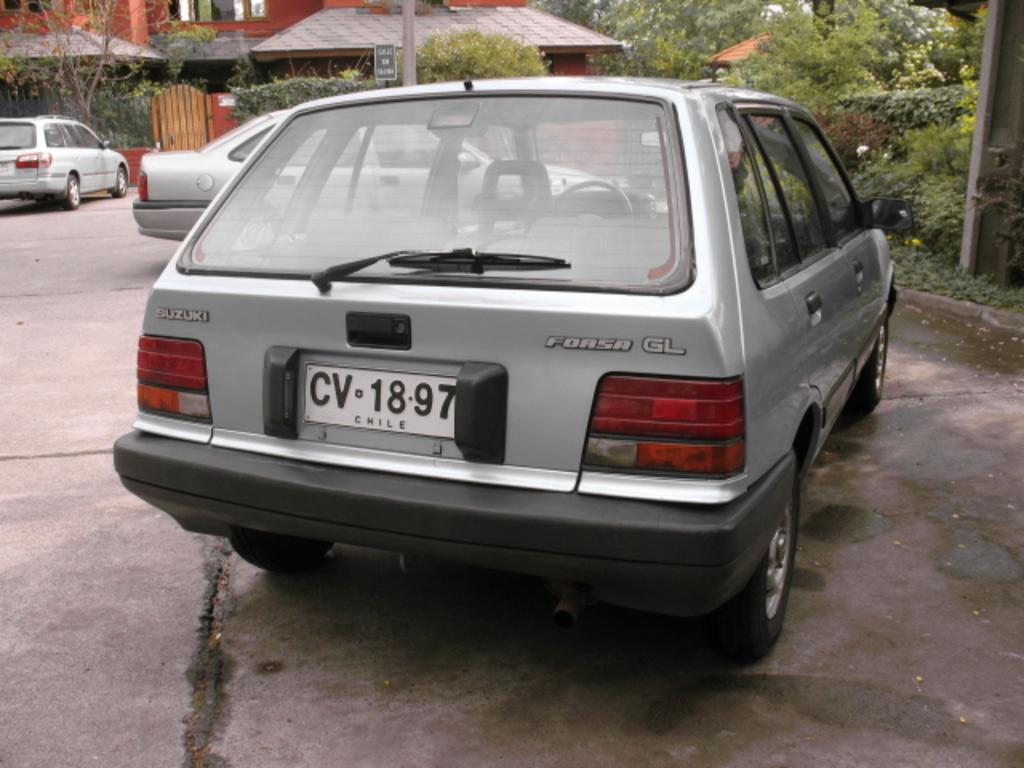How would you summarize this image in a sentence or two? In the picture we can see a house near it, we can see a gate outside the gate we can see some plant, car and the other two cars are parked besides to it and behind it we can see a group of plants. 